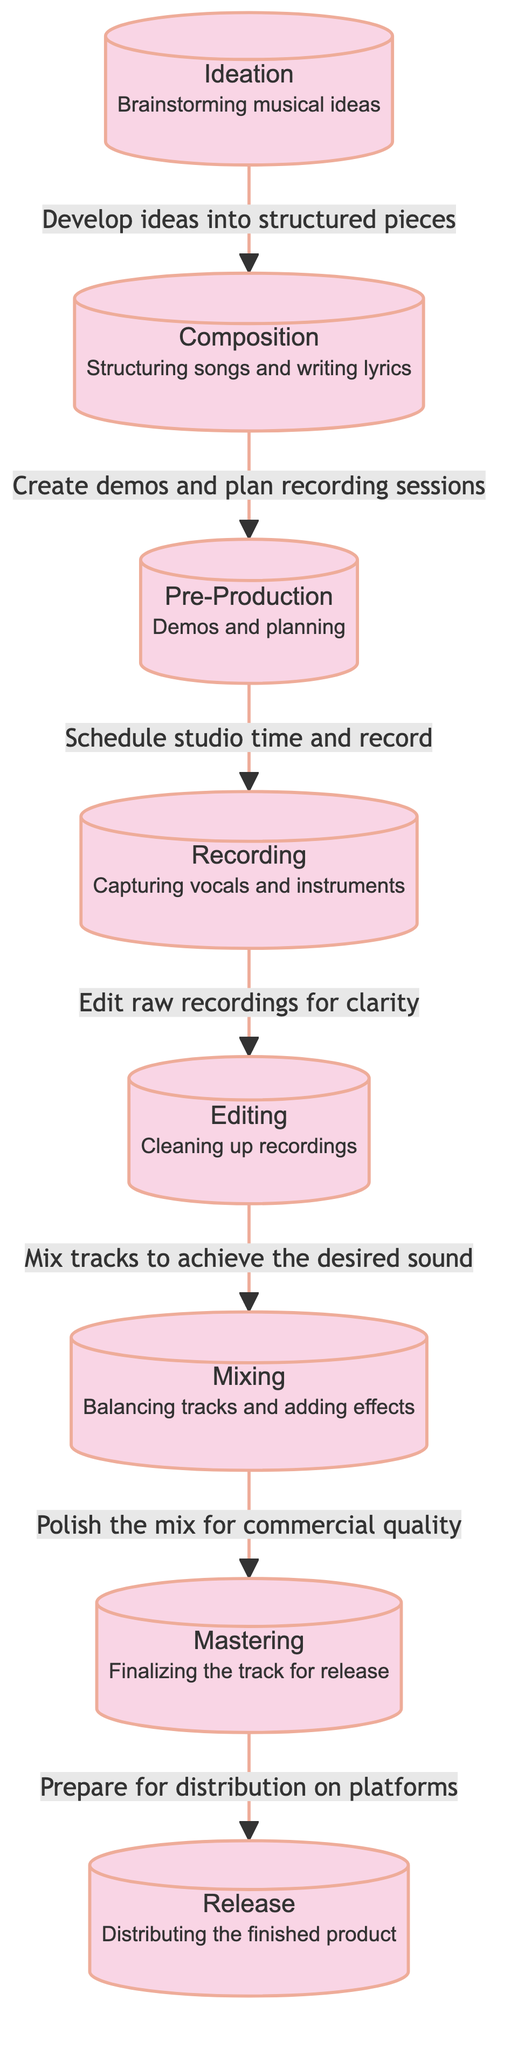What is the first stage in the music production workflow? The diagram clearly shows that the first stage is labeled "Ideation" which is involved in brainstorming musical ideas.
Answer: Ideation How many stages are there in the music production workflow? Counting the distinct nodes in the diagram reveals there are a total of 8 stages from Ideation to Release.
Answer: 8 What is the final stage before releasing the track? According to the diagram, the final stage before release is "Mastering," where the track is finalized for distribution.
Answer: Mastering Which stage comes directly after Recording? The flow of the diagram indicates that the stage following "Recording" is "Editing," which involves cleaning up the raw recordings.
Answer: Editing What action is associated with the transition from Editing to Mixing? The diagram shows that the action associated with this transition is to "Mix tracks to achieve the desired sound." This indicates the purpose of the Mixing stage.
Answer: Mix tracks to achieve the desired sound What stage involves capturing vocals and instruments? Referring to the diagram, the stage that involves capturing vocals and instruments is explicitly labeled "Recording."
Answer: Recording In what stage are demos and planning created? The diagram denotes that demos and planning are created during the "Pre-Production" stage of the workflow.
Answer: Pre-Production What is the connection between Composition and Pre-Production? The diagram indicates that the relationship is defined by the action "Create demos and plan recording sessions," which suggest the progression from Composition to Pre-Production.
Answer: Create demos and plan recording sessions How does the workflow progress from Mixing to Release? According to the diagram, the workflow progresses from Mixing, where the mix is polished for commercial quality, directly to the Release stage, which involves distribution.
Answer: Prepare for distribution on platforms 